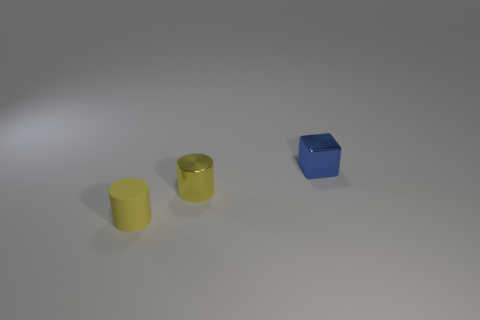Can you describe the shapes and colors visible in this image? There are two cylinders and one cube in this image. The cylinders have a yellow hue, one with a matte finish and the other with a more metallic sheen. The cube is colored blue with a glossy finish, and all objects are placed on a light-gray surface under a soft lighting condition. 